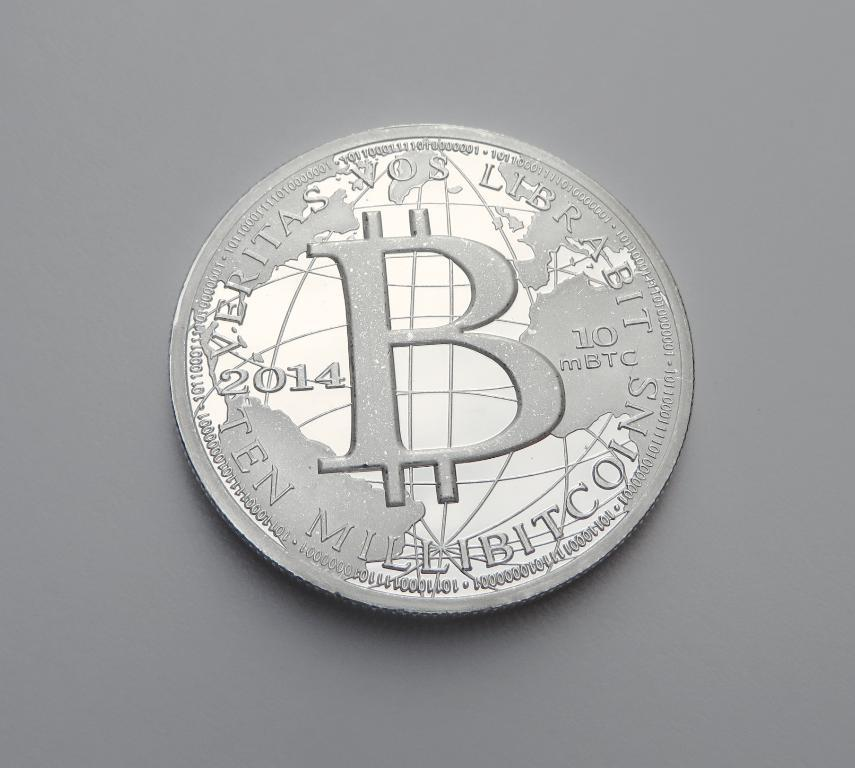<image>
Create a compact narrative representing the image presented. silver coin from 2014 that states verotas vos librabit 